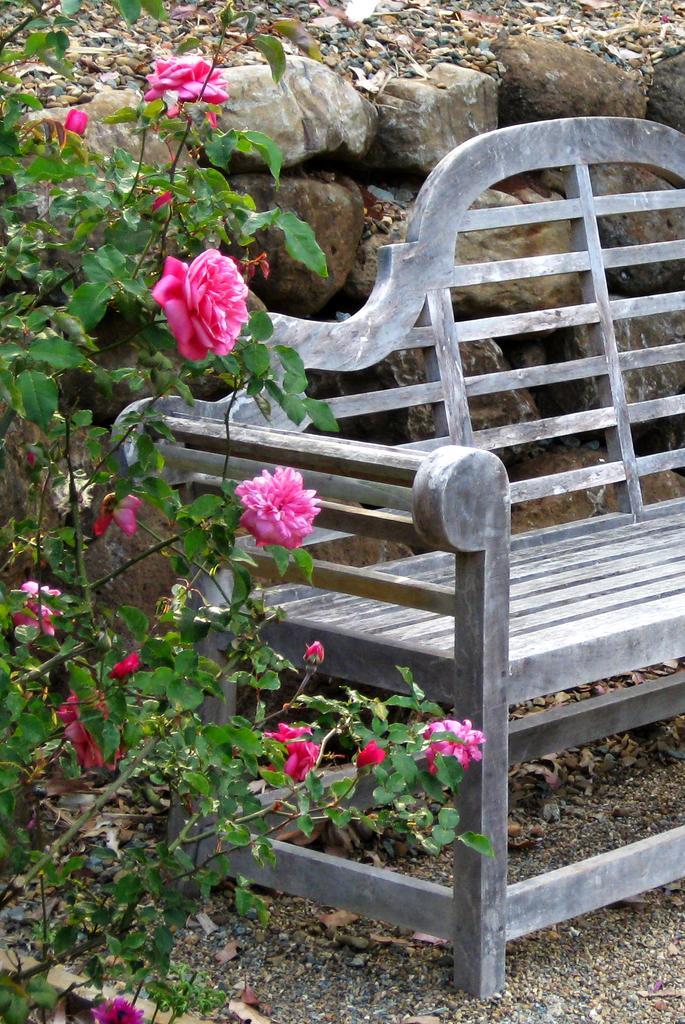Could you give a brief overview of what you see in this image? This picture may be taken from a garden. On the right there is a bench. On the left there is a plant of rose flowers. In the background there are stones and dry leaves. 